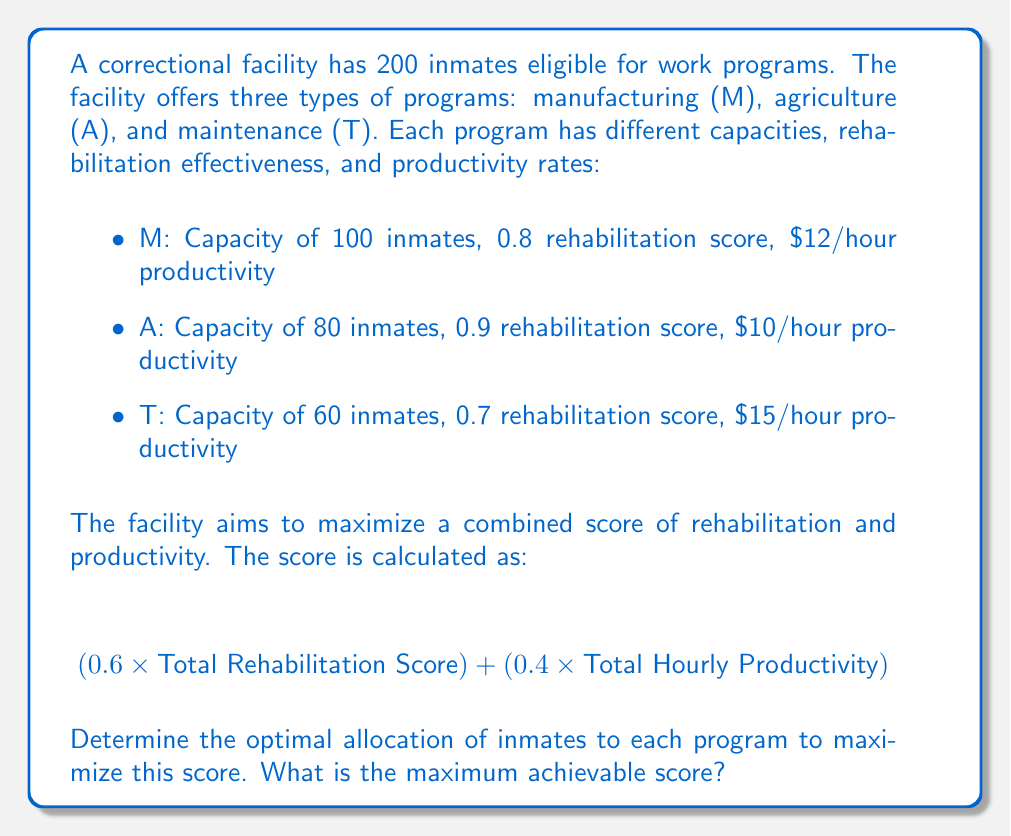What is the answer to this math problem? Let's approach this step-by-step using linear programming:

1) Define variables:
   Let $x_M$, $x_A$, and $x_T$ be the number of inmates assigned to manufacturing, agriculture, and maintenance respectively.

2) Objective function:
   We want to maximize:
   $$0.6(0.8x_M + 0.9x_A + 0.7x_T) + 0.4(12x_M + 10x_A + 15x_T)$$

3) Constraints:
   - Total inmates: $x_M + x_A + x_T \leq 200$
   - Capacity constraints: $x_M \leq 100$, $x_A \leq 80$, $x_T \leq 60$
   - Non-negativity: $x_M, x_A, x_T \geq 0$

4) Simplify the objective function:
   $$(0.6 \times 0.8 + 0.4 \times 12)x_M + (0.6 \times 0.9 + 0.4 \times 10)x_A + (0.6 \times 0.7 + 0.4 \times 15)x_T$$
   $$= 5.28x_M + 4.54x_A + 6.42x_T$$

5) Solve using the simplex method or linear programming software:
   The optimal solution is:
   $x_M = 100$, $x_A = 40$, $x_T = 60$

6) Calculate the maximum score:
   $5.28 \times 100 + 4.54 \times 40 + 6.42 \times 60 = 1093.6$

Therefore, the optimal allocation is to assign 100 inmates to manufacturing, 40 to agriculture, and 60 to maintenance.
Answer: The maximum achievable score is 1093.6. 